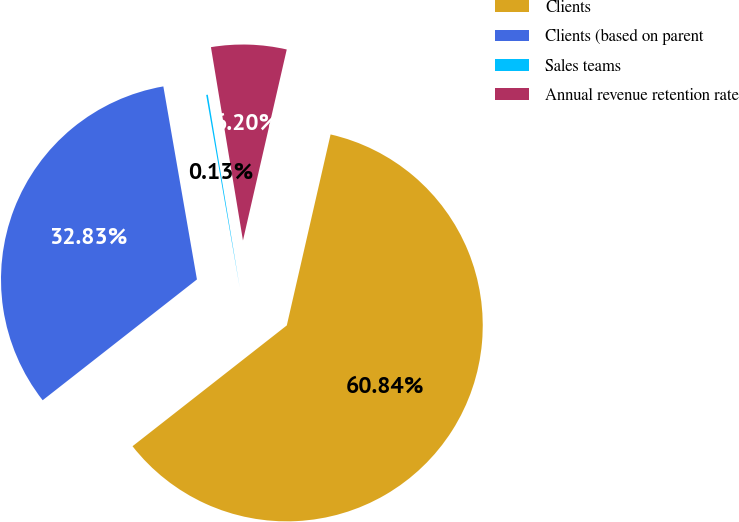Convert chart to OTSL. <chart><loc_0><loc_0><loc_500><loc_500><pie_chart><fcel>Clients<fcel>Clients (based on parent<fcel>Sales teams<fcel>Annual revenue retention rate<nl><fcel>60.84%<fcel>32.83%<fcel>0.13%<fcel>6.2%<nl></chart> 